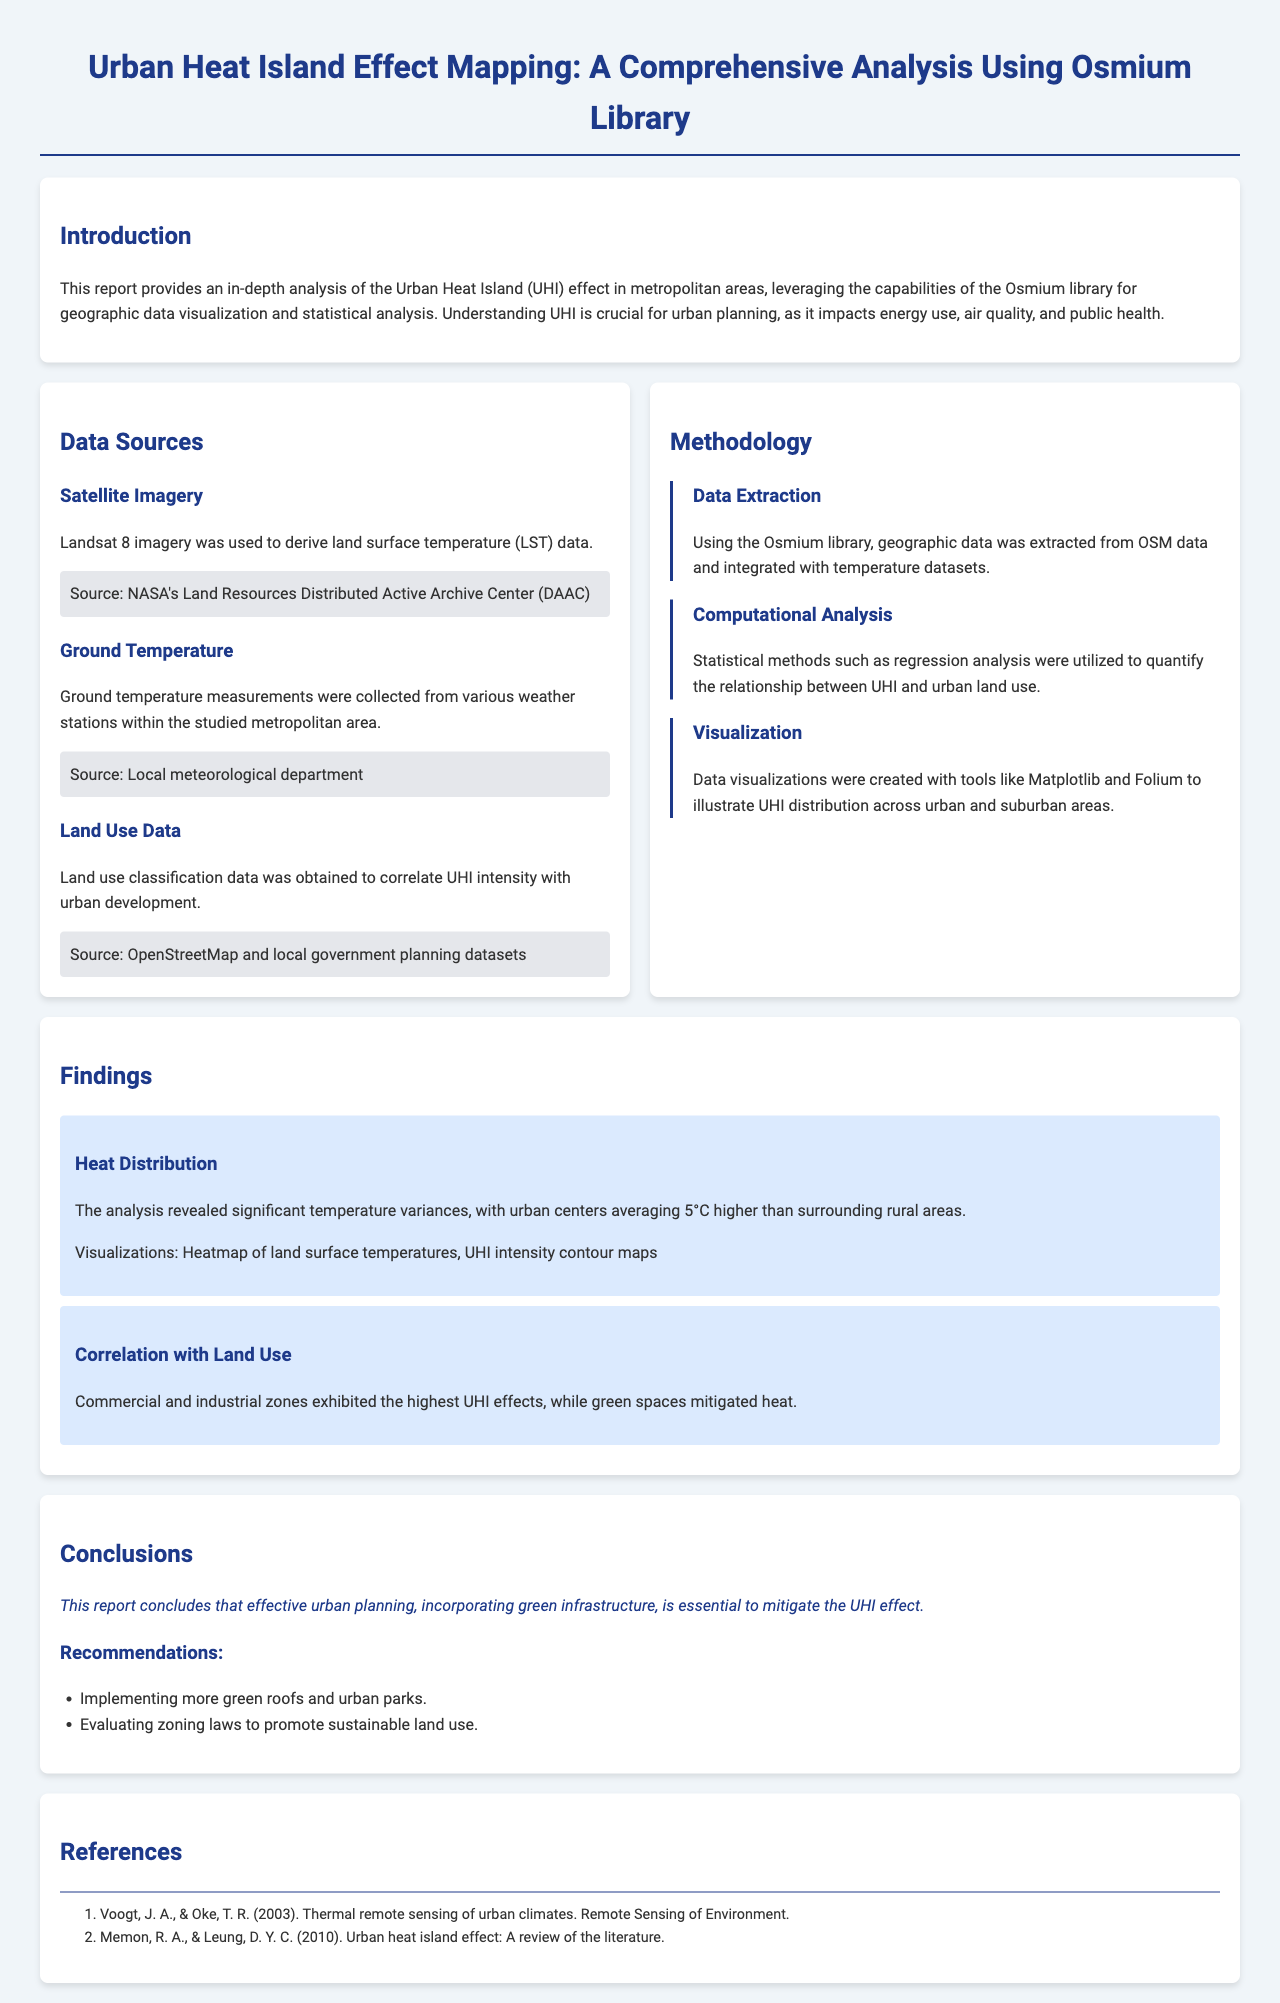what is the main focus of the report? The report focuses on analyzing the Urban Heat Island (UHI) effect in metropolitan areas using geographic data.
Answer: Urban Heat Island Effect which library is utilized for geographic data visualization in the report? The Osmium library is mentioned as the tool for geographic data visualization and statistical analysis.
Answer: Osmium library what is the temperature difference between urban centers and rural areas? The analysis indicates that urban centers average 5°C higher than surrounding rural areas.
Answer: 5°C which land use type had the highest UHI effects? The report states that commercial and industrial zones exhibited the highest UHI effects.
Answer: Commercial and industrial zones what is one recommendation provided in the conclusion section? The report suggests implementing more green roofs and urban parks as a recommendation to mitigate UHI.
Answer: Implementing more green roofs and urban parks which data source provided the ground temperature measurements? Ground temperature measurements were obtained from local weather stations.
Answer: Local meteorological department what type of visualizations were created to illustrate UHI distribution? The document mentions heatmaps and contour maps as the types of visualizations created.
Answer: Heatmap of land surface temperatures, UHI intensity contour maps who are the authors referenced in the literature section? The references include Voogt & Oke, and Memon & Leung as the authors cited.
Answer: Voogt, J. A., & Oke, T. R.; Memon, R. A., & Leung, D. Y. C 